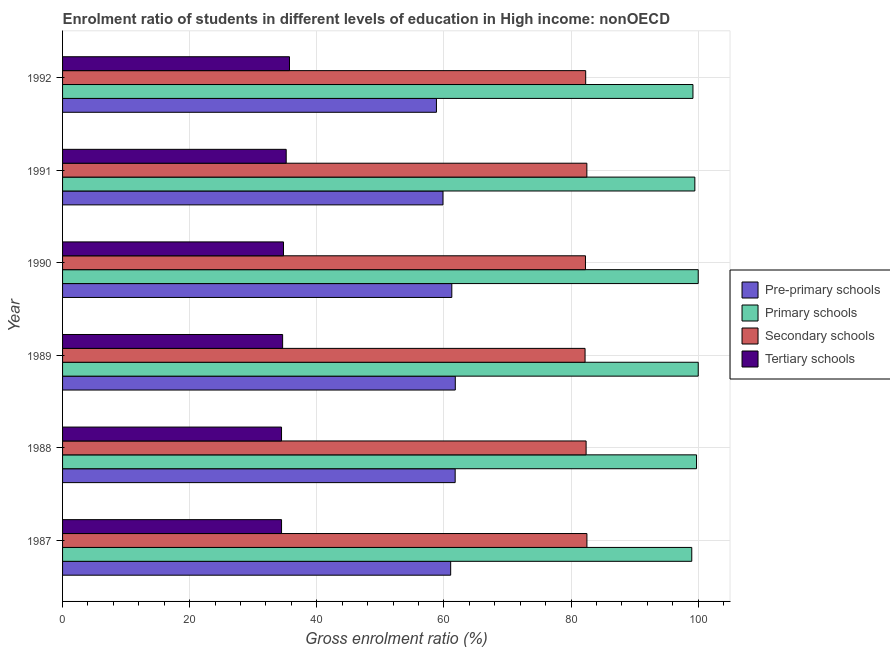Are the number of bars per tick equal to the number of legend labels?
Make the answer very short. Yes. What is the gross enrolment ratio in tertiary schools in 1989?
Provide a short and direct response. 34.62. Across all years, what is the maximum gross enrolment ratio in tertiary schools?
Offer a very short reply. 35.71. Across all years, what is the minimum gross enrolment ratio in primary schools?
Your answer should be compact. 99. What is the total gross enrolment ratio in pre-primary schools in the graph?
Provide a succinct answer. 364.56. What is the difference between the gross enrolment ratio in secondary schools in 1987 and that in 1990?
Your answer should be compact. 0.23. What is the difference between the gross enrolment ratio in pre-primary schools in 1987 and the gross enrolment ratio in secondary schools in 1992?
Keep it short and to the point. -21.24. What is the average gross enrolment ratio in secondary schools per year?
Your response must be concise. 82.36. In the year 1988, what is the difference between the gross enrolment ratio in tertiary schools and gross enrolment ratio in pre-primary schools?
Make the answer very short. -27.32. Is the difference between the gross enrolment ratio in tertiary schools in 1989 and 1992 greater than the difference between the gross enrolment ratio in primary schools in 1989 and 1992?
Your response must be concise. No. What is the difference between the highest and the second highest gross enrolment ratio in tertiary schools?
Your response must be concise. 0.52. What is the difference between the highest and the lowest gross enrolment ratio in primary schools?
Provide a succinct answer. 1.02. In how many years, is the gross enrolment ratio in pre-primary schools greater than the average gross enrolment ratio in pre-primary schools taken over all years?
Make the answer very short. 4. What does the 4th bar from the top in 1990 represents?
Ensure brevity in your answer.  Pre-primary schools. What does the 4th bar from the bottom in 1991 represents?
Provide a short and direct response. Tertiary schools. How many bars are there?
Provide a short and direct response. 24. How many years are there in the graph?
Provide a succinct answer. 6. What is the difference between two consecutive major ticks on the X-axis?
Make the answer very short. 20. Are the values on the major ticks of X-axis written in scientific E-notation?
Offer a very short reply. No. Does the graph contain grids?
Provide a short and direct response. Yes. How many legend labels are there?
Offer a terse response. 4. What is the title of the graph?
Offer a terse response. Enrolment ratio of students in different levels of education in High income: nonOECD. What is the label or title of the Y-axis?
Provide a succinct answer. Year. What is the Gross enrolment ratio (%) of Pre-primary schools in 1987?
Make the answer very short. 61.07. What is the Gross enrolment ratio (%) of Primary schools in 1987?
Offer a terse response. 99. What is the Gross enrolment ratio (%) of Secondary schools in 1987?
Offer a very short reply. 82.5. What is the Gross enrolment ratio (%) in Tertiary schools in 1987?
Keep it short and to the point. 34.46. What is the Gross enrolment ratio (%) in Pre-primary schools in 1988?
Your response must be concise. 61.77. What is the Gross enrolment ratio (%) in Primary schools in 1988?
Offer a very short reply. 99.75. What is the Gross enrolment ratio (%) in Secondary schools in 1988?
Offer a terse response. 82.38. What is the Gross enrolment ratio (%) in Tertiary schools in 1988?
Provide a short and direct response. 34.45. What is the Gross enrolment ratio (%) in Pre-primary schools in 1989?
Keep it short and to the point. 61.79. What is the Gross enrolment ratio (%) of Primary schools in 1989?
Provide a succinct answer. 100.02. What is the Gross enrolment ratio (%) in Secondary schools in 1989?
Provide a short and direct response. 82.21. What is the Gross enrolment ratio (%) in Tertiary schools in 1989?
Your answer should be compact. 34.62. What is the Gross enrolment ratio (%) of Pre-primary schools in 1990?
Ensure brevity in your answer.  61.25. What is the Gross enrolment ratio (%) of Primary schools in 1990?
Give a very brief answer. 100.02. What is the Gross enrolment ratio (%) in Secondary schools in 1990?
Keep it short and to the point. 82.27. What is the Gross enrolment ratio (%) in Tertiary schools in 1990?
Ensure brevity in your answer.  34.76. What is the Gross enrolment ratio (%) of Pre-primary schools in 1991?
Your answer should be compact. 59.86. What is the Gross enrolment ratio (%) in Primary schools in 1991?
Your answer should be very brief. 99.49. What is the Gross enrolment ratio (%) in Secondary schools in 1991?
Provide a short and direct response. 82.49. What is the Gross enrolment ratio (%) in Tertiary schools in 1991?
Your answer should be compact. 35.19. What is the Gross enrolment ratio (%) of Pre-primary schools in 1992?
Your response must be concise. 58.83. What is the Gross enrolment ratio (%) of Primary schools in 1992?
Make the answer very short. 99.19. What is the Gross enrolment ratio (%) of Secondary schools in 1992?
Ensure brevity in your answer.  82.31. What is the Gross enrolment ratio (%) in Tertiary schools in 1992?
Make the answer very short. 35.71. Across all years, what is the maximum Gross enrolment ratio (%) of Pre-primary schools?
Provide a succinct answer. 61.79. Across all years, what is the maximum Gross enrolment ratio (%) in Primary schools?
Provide a short and direct response. 100.02. Across all years, what is the maximum Gross enrolment ratio (%) of Secondary schools?
Keep it short and to the point. 82.5. Across all years, what is the maximum Gross enrolment ratio (%) of Tertiary schools?
Make the answer very short. 35.71. Across all years, what is the minimum Gross enrolment ratio (%) in Pre-primary schools?
Provide a short and direct response. 58.83. Across all years, what is the minimum Gross enrolment ratio (%) of Primary schools?
Your answer should be very brief. 99. Across all years, what is the minimum Gross enrolment ratio (%) of Secondary schools?
Ensure brevity in your answer.  82.21. Across all years, what is the minimum Gross enrolment ratio (%) of Tertiary schools?
Make the answer very short. 34.45. What is the total Gross enrolment ratio (%) of Pre-primary schools in the graph?
Ensure brevity in your answer.  364.56. What is the total Gross enrolment ratio (%) of Primary schools in the graph?
Ensure brevity in your answer.  597.46. What is the total Gross enrolment ratio (%) in Secondary schools in the graph?
Provide a succinct answer. 494.17. What is the total Gross enrolment ratio (%) in Tertiary schools in the graph?
Give a very brief answer. 209.19. What is the difference between the Gross enrolment ratio (%) of Pre-primary schools in 1987 and that in 1988?
Offer a very short reply. -0.71. What is the difference between the Gross enrolment ratio (%) of Primary schools in 1987 and that in 1988?
Give a very brief answer. -0.75. What is the difference between the Gross enrolment ratio (%) in Secondary schools in 1987 and that in 1988?
Your answer should be compact. 0.13. What is the difference between the Gross enrolment ratio (%) in Tertiary schools in 1987 and that in 1988?
Your answer should be compact. 0. What is the difference between the Gross enrolment ratio (%) in Pre-primary schools in 1987 and that in 1989?
Your response must be concise. -0.73. What is the difference between the Gross enrolment ratio (%) of Primary schools in 1987 and that in 1989?
Your answer should be very brief. -1.02. What is the difference between the Gross enrolment ratio (%) in Secondary schools in 1987 and that in 1989?
Offer a very short reply. 0.29. What is the difference between the Gross enrolment ratio (%) in Tertiary schools in 1987 and that in 1989?
Your response must be concise. -0.17. What is the difference between the Gross enrolment ratio (%) in Pre-primary schools in 1987 and that in 1990?
Offer a terse response. -0.18. What is the difference between the Gross enrolment ratio (%) in Primary schools in 1987 and that in 1990?
Keep it short and to the point. -1.01. What is the difference between the Gross enrolment ratio (%) in Secondary schools in 1987 and that in 1990?
Give a very brief answer. 0.23. What is the difference between the Gross enrolment ratio (%) in Tertiary schools in 1987 and that in 1990?
Your answer should be very brief. -0.31. What is the difference between the Gross enrolment ratio (%) of Pre-primary schools in 1987 and that in 1991?
Your answer should be very brief. 1.21. What is the difference between the Gross enrolment ratio (%) in Primary schools in 1987 and that in 1991?
Offer a very short reply. -0.48. What is the difference between the Gross enrolment ratio (%) in Secondary schools in 1987 and that in 1991?
Ensure brevity in your answer.  0.01. What is the difference between the Gross enrolment ratio (%) in Tertiary schools in 1987 and that in 1991?
Offer a terse response. -0.73. What is the difference between the Gross enrolment ratio (%) of Pre-primary schools in 1987 and that in 1992?
Provide a succinct answer. 2.24. What is the difference between the Gross enrolment ratio (%) in Primary schools in 1987 and that in 1992?
Offer a very short reply. -0.19. What is the difference between the Gross enrolment ratio (%) of Secondary schools in 1987 and that in 1992?
Make the answer very short. 0.19. What is the difference between the Gross enrolment ratio (%) of Tertiary schools in 1987 and that in 1992?
Your answer should be very brief. -1.25. What is the difference between the Gross enrolment ratio (%) in Pre-primary schools in 1988 and that in 1989?
Keep it short and to the point. -0.02. What is the difference between the Gross enrolment ratio (%) of Primary schools in 1988 and that in 1989?
Provide a succinct answer. -0.27. What is the difference between the Gross enrolment ratio (%) of Secondary schools in 1988 and that in 1989?
Offer a very short reply. 0.16. What is the difference between the Gross enrolment ratio (%) in Tertiary schools in 1988 and that in 1989?
Keep it short and to the point. -0.17. What is the difference between the Gross enrolment ratio (%) of Pre-primary schools in 1988 and that in 1990?
Your answer should be compact. 0.53. What is the difference between the Gross enrolment ratio (%) of Primary schools in 1988 and that in 1990?
Offer a terse response. -0.27. What is the difference between the Gross enrolment ratio (%) in Secondary schools in 1988 and that in 1990?
Your answer should be very brief. 0.1. What is the difference between the Gross enrolment ratio (%) in Tertiary schools in 1988 and that in 1990?
Your answer should be compact. -0.31. What is the difference between the Gross enrolment ratio (%) in Pre-primary schools in 1988 and that in 1991?
Provide a succinct answer. 1.92. What is the difference between the Gross enrolment ratio (%) of Primary schools in 1988 and that in 1991?
Your response must be concise. 0.27. What is the difference between the Gross enrolment ratio (%) of Secondary schools in 1988 and that in 1991?
Your response must be concise. -0.12. What is the difference between the Gross enrolment ratio (%) in Tertiary schools in 1988 and that in 1991?
Your response must be concise. -0.74. What is the difference between the Gross enrolment ratio (%) in Pre-primary schools in 1988 and that in 1992?
Your answer should be very brief. 2.95. What is the difference between the Gross enrolment ratio (%) of Primary schools in 1988 and that in 1992?
Keep it short and to the point. 0.56. What is the difference between the Gross enrolment ratio (%) of Secondary schools in 1988 and that in 1992?
Provide a short and direct response. 0.07. What is the difference between the Gross enrolment ratio (%) of Tertiary schools in 1988 and that in 1992?
Make the answer very short. -1.25. What is the difference between the Gross enrolment ratio (%) of Pre-primary schools in 1989 and that in 1990?
Give a very brief answer. 0.55. What is the difference between the Gross enrolment ratio (%) of Primary schools in 1989 and that in 1990?
Your answer should be very brief. 0. What is the difference between the Gross enrolment ratio (%) in Secondary schools in 1989 and that in 1990?
Offer a terse response. -0.06. What is the difference between the Gross enrolment ratio (%) of Tertiary schools in 1989 and that in 1990?
Make the answer very short. -0.14. What is the difference between the Gross enrolment ratio (%) of Pre-primary schools in 1989 and that in 1991?
Make the answer very short. 1.94. What is the difference between the Gross enrolment ratio (%) of Primary schools in 1989 and that in 1991?
Keep it short and to the point. 0.53. What is the difference between the Gross enrolment ratio (%) in Secondary schools in 1989 and that in 1991?
Give a very brief answer. -0.28. What is the difference between the Gross enrolment ratio (%) of Tertiary schools in 1989 and that in 1991?
Provide a short and direct response. -0.56. What is the difference between the Gross enrolment ratio (%) of Pre-primary schools in 1989 and that in 1992?
Your answer should be compact. 2.97. What is the difference between the Gross enrolment ratio (%) in Primary schools in 1989 and that in 1992?
Offer a terse response. 0.83. What is the difference between the Gross enrolment ratio (%) of Secondary schools in 1989 and that in 1992?
Make the answer very short. -0.1. What is the difference between the Gross enrolment ratio (%) in Tertiary schools in 1989 and that in 1992?
Your answer should be compact. -1.08. What is the difference between the Gross enrolment ratio (%) of Pre-primary schools in 1990 and that in 1991?
Make the answer very short. 1.39. What is the difference between the Gross enrolment ratio (%) in Primary schools in 1990 and that in 1991?
Provide a short and direct response. 0.53. What is the difference between the Gross enrolment ratio (%) of Secondary schools in 1990 and that in 1991?
Offer a very short reply. -0.22. What is the difference between the Gross enrolment ratio (%) of Tertiary schools in 1990 and that in 1991?
Offer a very short reply. -0.42. What is the difference between the Gross enrolment ratio (%) in Pre-primary schools in 1990 and that in 1992?
Your answer should be compact. 2.42. What is the difference between the Gross enrolment ratio (%) of Primary schools in 1990 and that in 1992?
Provide a succinct answer. 0.83. What is the difference between the Gross enrolment ratio (%) of Secondary schools in 1990 and that in 1992?
Your response must be concise. -0.04. What is the difference between the Gross enrolment ratio (%) in Tertiary schools in 1990 and that in 1992?
Your answer should be very brief. -0.94. What is the difference between the Gross enrolment ratio (%) of Pre-primary schools in 1991 and that in 1992?
Provide a short and direct response. 1.03. What is the difference between the Gross enrolment ratio (%) in Primary schools in 1991 and that in 1992?
Ensure brevity in your answer.  0.3. What is the difference between the Gross enrolment ratio (%) of Secondary schools in 1991 and that in 1992?
Give a very brief answer. 0.19. What is the difference between the Gross enrolment ratio (%) of Tertiary schools in 1991 and that in 1992?
Offer a very short reply. -0.52. What is the difference between the Gross enrolment ratio (%) of Pre-primary schools in 1987 and the Gross enrolment ratio (%) of Primary schools in 1988?
Keep it short and to the point. -38.69. What is the difference between the Gross enrolment ratio (%) of Pre-primary schools in 1987 and the Gross enrolment ratio (%) of Secondary schools in 1988?
Provide a succinct answer. -21.31. What is the difference between the Gross enrolment ratio (%) of Pre-primary schools in 1987 and the Gross enrolment ratio (%) of Tertiary schools in 1988?
Offer a very short reply. 26.61. What is the difference between the Gross enrolment ratio (%) of Primary schools in 1987 and the Gross enrolment ratio (%) of Secondary schools in 1988?
Keep it short and to the point. 16.63. What is the difference between the Gross enrolment ratio (%) in Primary schools in 1987 and the Gross enrolment ratio (%) in Tertiary schools in 1988?
Provide a succinct answer. 64.55. What is the difference between the Gross enrolment ratio (%) of Secondary schools in 1987 and the Gross enrolment ratio (%) of Tertiary schools in 1988?
Your response must be concise. 48.05. What is the difference between the Gross enrolment ratio (%) in Pre-primary schools in 1987 and the Gross enrolment ratio (%) in Primary schools in 1989?
Your response must be concise. -38.95. What is the difference between the Gross enrolment ratio (%) of Pre-primary schools in 1987 and the Gross enrolment ratio (%) of Secondary schools in 1989?
Provide a short and direct response. -21.15. What is the difference between the Gross enrolment ratio (%) in Pre-primary schools in 1987 and the Gross enrolment ratio (%) in Tertiary schools in 1989?
Make the answer very short. 26.44. What is the difference between the Gross enrolment ratio (%) in Primary schools in 1987 and the Gross enrolment ratio (%) in Secondary schools in 1989?
Ensure brevity in your answer.  16.79. What is the difference between the Gross enrolment ratio (%) in Primary schools in 1987 and the Gross enrolment ratio (%) in Tertiary schools in 1989?
Make the answer very short. 64.38. What is the difference between the Gross enrolment ratio (%) of Secondary schools in 1987 and the Gross enrolment ratio (%) of Tertiary schools in 1989?
Provide a succinct answer. 47.88. What is the difference between the Gross enrolment ratio (%) of Pre-primary schools in 1987 and the Gross enrolment ratio (%) of Primary schools in 1990?
Keep it short and to the point. -38.95. What is the difference between the Gross enrolment ratio (%) of Pre-primary schools in 1987 and the Gross enrolment ratio (%) of Secondary schools in 1990?
Offer a very short reply. -21.21. What is the difference between the Gross enrolment ratio (%) of Pre-primary schools in 1987 and the Gross enrolment ratio (%) of Tertiary schools in 1990?
Your answer should be very brief. 26.3. What is the difference between the Gross enrolment ratio (%) of Primary schools in 1987 and the Gross enrolment ratio (%) of Secondary schools in 1990?
Your response must be concise. 16.73. What is the difference between the Gross enrolment ratio (%) of Primary schools in 1987 and the Gross enrolment ratio (%) of Tertiary schools in 1990?
Provide a short and direct response. 64.24. What is the difference between the Gross enrolment ratio (%) of Secondary schools in 1987 and the Gross enrolment ratio (%) of Tertiary schools in 1990?
Provide a succinct answer. 47.74. What is the difference between the Gross enrolment ratio (%) in Pre-primary schools in 1987 and the Gross enrolment ratio (%) in Primary schools in 1991?
Your answer should be compact. -38.42. What is the difference between the Gross enrolment ratio (%) in Pre-primary schools in 1987 and the Gross enrolment ratio (%) in Secondary schools in 1991?
Offer a very short reply. -21.43. What is the difference between the Gross enrolment ratio (%) of Pre-primary schools in 1987 and the Gross enrolment ratio (%) of Tertiary schools in 1991?
Make the answer very short. 25.88. What is the difference between the Gross enrolment ratio (%) of Primary schools in 1987 and the Gross enrolment ratio (%) of Secondary schools in 1991?
Your answer should be compact. 16.51. What is the difference between the Gross enrolment ratio (%) in Primary schools in 1987 and the Gross enrolment ratio (%) in Tertiary schools in 1991?
Your answer should be compact. 63.81. What is the difference between the Gross enrolment ratio (%) in Secondary schools in 1987 and the Gross enrolment ratio (%) in Tertiary schools in 1991?
Make the answer very short. 47.32. What is the difference between the Gross enrolment ratio (%) of Pre-primary schools in 1987 and the Gross enrolment ratio (%) of Primary schools in 1992?
Your answer should be very brief. -38.12. What is the difference between the Gross enrolment ratio (%) of Pre-primary schools in 1987 and the Gross enrolment ratio (%) of Secondary schools in 1992?
Offer a very short reply. -21.24. What is the difference between the Gross enrolment ratio (%) of Pre-primary schools in 1987 and the Gross enrolment ratio (%) of Tertiary schools in 1992?
Offer a very short reply. 25.36. What is the difference between the Gross enrolment ratio (%) of Primary schools in 1987 and the Gross enrolment ratio (%) of Secondary schools in 1992?
Your response must be concise. 16.69. What is the difference between the Gross enrolment ratio (%) of Primary schools in 1987 and the Gross enrolment ratio (%) of Tertiary schools in 1992?
Offer a very short reply. 63.29. What is the difference between the Gross enrolment ratio (%) of Secondary schools in 1987 and the Gross enrolment ratio (%) of Tertiary schools in 1992?
Your response must be concise. 46.8. What is the difference between the Gross enrolment ratio (%) of Pre-primary schools in 1988 and the Gross enrolment ratio (%) of Primary schools in 1989?
Ensure brevity in your answer.  -38.25. What is the difference between the Gross enrolment ratio (%) in Pre-primary schools in 1988 and the Gross enrolment ratio (%) in Secondary schools in 1989?
Offer a very short reply. -20.44. What is the difference between the Gross enrolment ratio (%) of Pre-primary schools in 1988 and the Gross enrolment ratio (%) of Tertiary schools in 1989?
Give a very brief answer. 27.15. What is the difference between the Gross enrolment ratio (%) in Primary schools in 1988 and the Gross enrolment ratio (%) in Secondary schools in 1989?
Your answer should be very brief. 17.54. What is the difference between the Gross enrolment ratio (%) of Primary schools in 1988 and the Gross enrolment ratio (%) of Tertiary schools in 1989?
Give a very brief answer. 65.13. What is the difference between the Gross enrolment ratio (%) of Secondary schools in 1988 and the Gross enrolment ratio (%) of Tertiary schools in 1989?
Offer a terse response. 47.75. What is the difference between the Gross enrolment ratio (%) in Pre-primary schools in 1988 and the Gross enrolment ratio (%) in Primary schools in 1990?
Offer a very short reply. -38.24. What is the difference between the Gross enrolment ratio (%) of Pre-primary schools in 1988 and the Gross enrolment ratio (%) of Secondary schools in 1990?
Offer a very short reply. -20.5. What is the difference between the Gross enrolment ratio (%) in Pre-primary schools in 1988 and the Gross enrolment ratio (%) in Tertiary schools in 1990?
Offer a very short reply. 27.01. What is the difference between the Gross enrolment ratio (%) of Primary schools in 1988 and the Gross enrolment ratio (%) of Secondary schools in 1990?
Give a very brief answer. 17.48. What is the difference between the Gross enrolment ratio (%) of Primary schools in 1988 and the Gross enrolment ratio (%) of Tertiary schools in 1990?
Your answer should be compact. 64.99. What is the difference between the Gross enrolment ratio (%) in Secondary schools in 1988 and the Gross enrolment ratio (%) in Tertiary schools in 1990?
Your answer should be compact. 47.61. What is the difference between the Gross enrolment ratio (%) of Pre-primary schools in 1988 and the Gross enrolment ratio (%) of Primary schools in 1991?
Your answer should be very brief. -37.71. What is the difference between the Gross enrolment ratio (%) of Pre-primary schools in 1988 and the Gross enrolment ratio (%) of Secondary schools in 1991?
Keep it short and to the point. -20.72. What is the difference between the Gross enrolment ratio (%) in Pre-primary schools in 1988 and the Gross enrolment ratio (%) in Tertiary schools in 1991?
Your answer should be compact. 26.59. What is the difference between the Gross enrolment ratio (%) in Primary schools in 1988 and the Gross enrolment ratio (%) in Secondary schools in 1991?
Your answer should be very brief. 17.26. What is the difference between the Gross enrolment ratio (%) in Primary schools in 1988 and the Gross enrolment ratio (%) in Tertiary schools in 1991?
Your answer should be compact. 64.56. What is the difference between the Gross enrolment ratio (%) in Secondary schools in 1988 and the Gross enrolment ratio (%) in Tertiary schools in 1991?
Offer a terse response. 47.19. What is the difference between the Gross enrolment ratio (%) of Pre-primary schools in 1988 and the Gross enrolment ratio (%) of Primary schools in 1992?
Your response must be concise. -37.41. What is the difference between the Gross enrolment ratio (%) in Pre-primary schools in 1988 and the Gross enrolment ratio (%) in Secondary schools in 1992?
Offer a very short reply. -20.54. What is the difference between the Gross enrolment ratio (%) in Pre-primary schools in 1988 and the Gross enrolment ratio (%) in Tertiary schools in 1992?
Provide a short and direct response. 26.07. What is the difference between the Gross enrolment ratio (%) in Primary schools in 1988 and the Gross enrolment ratio (%) in Secondary schools in 1992?
Make the answer very short. 17.44. What is the difference between the Gross enrolment ratio (%) of Primary schools in 1988 and the Gross enrolment ratio (%) of Tertiary schools in 1992?
Provide a succinct answer. 64.04. What is the difference between the Gross enrolment ratio (%) of Secondary schools in 1988 and the Gross enrolment ratio (%) of Tertiary schools in 1992?
Your response must be concise. 46.67. What is the difference between the Gross enrolment ratio (%) in Pre-primary schools in 1989 and the Gross enrolment ratio (%) in Primary schools in 1990?
Provide a succinct answer. -38.22. What is the difference between the Gross enrolment ratio (%) in Pre-primary schools in 1989 and the Gross enrolment ratio (%) in Secondary schools in 1990?
Offer a terse response. -20.48. What is the difference between the Gross enrolment ratio (%) of Pre-primary schools in 1989 and the Gross enrolment ratio (%) of Tertiary schools in 1990?
Keep it short and to the point. 27.03. What is the difference between the Gross enrolment ratio (%) in Primary schools in 1989 and the Gross enrolment ratio (%) in Secondary schools in 1990?
Make the answer very short. 17.74. What is the difference between the Gross enrolment ratio (%) of Primary schools in 1989 and the Gross enrolment ratio (%) of Tertiary schools in 1990?
Offer a very short reply. 65.26. What is the difference between the Gross enrolment ratio (%) in Secondary schools in 1989 and the Gross enrolment ratio (%) in Tertiary schools in 1990?
Your answer should be compact. 47.45. What is the difference between the Gross enrolment ratio (%) of Pre-primary schools in 1989 and the Gross enrolment ratio (%) of Primary schools in 1991?
Offer a very short reply. -37.69. What is the difference between the Gross enrolment ratio (%) of Pre-primary schools in 1989 and the Gross enrolment ratio (%) of Secondary schools in 1991?
Make the answer very short. -20.7. What is the difference between the Gross enrolment ratio (%) of Pre-primary schools in 1989 and the Gross enrolment ratio (%) of Tertiary schools in 1991?
Ensure brevity in your answer.  26.61. What is the difference between the Gross enrolment ratio (%) of Primary schools in 1989 and the Gross enrolment ratio (%) of Secondary schools in 1991?
Ensure brevity in your answer.  17.52. What is the difference between the Gross enrolment ratio (%) of Primary schools in 1989 and the Gross enrolment ratio (%) of Tertiary schools in 1991?
Offer a terse response. 64.83. What is the difference between the Gross enrolment ratio (%) in Secondary schools in 1989 and the Gross enrolment ratio (%) in Tertiary schools in 1991?
Provide a short and direct response. 47.02. What is the difference between the Gross enrolment ratio (%) in Pre-primary schools in 1989 and the Gross enrolment ratio (%) in Primary schools in 1992?
Your answer should be compact. -37.39. What is the difference between the Gross enrolment ratio (%) in Pre-primary schools in 1989 and the Gross enrolment ratio (%) in Secondary schools in 1992?
Your answer should be compact. -20.51. What is the difference between the Gross enrolment ratio (%) of Pre-primary schools in 1989 and the Gross enrolment ratio (%) of Tertiary schools in 1992?
Make the answer very short. 26.09. What is the difference between the Gross enrolment ratio (%) of Primary schools in 1989 and the Gross enrolment ratio (%) of Secondary schools in 1992?
Make the answer very short. 17.71. What is the difference between the Gross enrolment ratio (%) in Primary schools in 1989 and the Gross enrolment ratio (%) in Tertiary schools in 1992?
Offer a very short reply. 64.31. What is the difference between the Gross enrolment ratio (%) in Secondary schools in 1989 and the Gross enrolment ratio (%) in Tertiary schools in 1992?
Keep it short and to the point. 46.5. What is the difference between the Gross enrolment ratio (%) of Pre-primary schools in 1990 and the Gross enrolment ratio (%) of Primary schools in 1991?
Ensure brevity in your answer.  -38.24. What is the difference between the Gross enrolment ratio (%) of Pre-primary schools in 1990 and the Gross enrolment ratio (%) of Secondary schools in 1991?
Keep it short and to the point. -21.25. What is the difference between the Gross enrolment ratio (%) of Pre-primary schools in 1990 and the Gross enrolment ratio (%) of Tertiary schools in 1991?
Give a very brief answer. 26.06. What is the difference between the Gross enrolment ratio (%) of Primary schools in 1990 and the Gross enrolment ratio (%) of Secondary schools in 1991?
Provide a short and direct response. 17.52. What is the difference between the Gross enrolment ratio (%) in Primary schools in 1990 and the Gross enrolment ratio (%) in Tertiary schools in 1991?
Your response must be concise. 64.83. What is the difference between the Gross enrolment ratio (%) in Secondary schools in 1990 and the Gross enrolment ratio (%) in Tertiary schools in 1991?
Provide a succinct answer. 47.09. What is the difference between the Gross enrolment ratio (%) in Pre-primary schools in 1990 and the Gross enrolment ratio (%) in Primary schools in 1992?
Ensure brevity in your answer.  -37.94. What is the difference between the Gross enrolment ratio (%) of Pre-primary schools in 1990 and the Gross enrolment ratio (%) of Secondary schools in 1992?
Offer a very short reply. -21.06. What is the difference between the Gross enrolment ratio (%) in Pre-primary schools in 1990 and the Gross enrolment ratio (%) in Tertiary schools in 1992?
Your answer should be very brief. 25.54. What is the difference between the Gross enrolment ratio (%) of Primary schools in 1990 and the Gross enrolment ratio (%) of Secondary schools in 1992?
Offer a very short reply. 17.71. What is the difference between the Gross enrolment ratio (%) of Primary schools in 1990 and the Gross enrolment ratio (%) of Tertiary schools in 1992?
Ensure brevity in your answer.  64.31. What is the difference between the Gross enrolment ratio (%) of Secondary schools in 1990 and the Gross enrolment ratio (%) of Tertiary schools in 1992?
Your answer should be very brief. 46.57. What is the difference between the Gross enrolment ratio (%) in Pre-primary schools in 1991 and the Gross enrolment ratio (%) in Primary schools in 1992?
Offer a terse response. -39.33. What is the difference between the Gross enrolment ratio (%) of Pre-primary schools in 1991 and the Gross enrolment ratio (%) of Secondary schools in 1992?
Provide a succinct answer. -22.45. What is the difference between the Gross enrolment ratio (%) of Pre-primary schools in 1991 and the Gross enrolment ratio (%) of Tertiary schools in 1992?
Make the answer very short. 24.15. What is the difference between the Gross enrolment ratio (%) of Primary schools in 1991 and the Gross enrolment ratio (%) of Secondary schools in 1992?
Make the answer very short. 17.18. What is the difference between the Gross enrolment ratio (%) in Primary schools in 1991 and the Gross enrolment ratio (%) in Tertiary schools in 1992?
Your response must be concise. 63.78. What is the difference between the Gross enrolment ratio (%) of Secondary schools in 1991 and the Gross enrolment ratio (%) of Tertiary schools in 1992?
Your answer should be compact. 46.79. What is the average Gross enrolment ratio (%) in Pre-primary schools per year?
Your answer should be compact. 60.76. What is the average Gross enrolment ratio (%) of Primary schools per year?
Ensure brevity in your answer.  99.58. What is the average Gross enrolment ratio (%) of Secondary schools per year?
Offer a terse response. 82.36. What is the average Gross enrolment ratio (%) in Tertiary schools per year?
Offer a very short reply. 34.87. In the year 1987, what is the difference between the Gross enrolment ratio (%) of Pre-primary schools and Gross enrolment ratio (%) of Primary schools?
Ensure brevity in your answer.  -37.94. In the year 1987, what is the difference between the Gross enrolment ratio (%) of Pre-primary schools and Gross enrolment ratio (%) of Secondary schools?
Give a very brief answer. -21.44. In the year 1987, what is the difference between the Gross enrolment ratio (%) in Pre-primary schools and Gross enrolment ratio (%) in Tertiary schools?
Your answer should be very brief. 26.61. In the year 1987, what is the difference between the Gross enrolment ratio (%) in Primary schools and Gross enrolment ratio (%) in Secondary schools?
Provide a short and direct response. 16.5. In the year 1987, what is the difference between the Gross enrolment ratio (%) in Primary schools and Gross enrolment ratio (%) in Tertiary schools?
Your response must be concise. 64.54. In the year 1987, what is the difference between the Gross enrolment ratio (%) of Secondary schools and Gross enrolment ratio (%) of Tertiary schools?
Give a very brief answer. 48.05. In the year 1988, what is the difference between the Gross enrolment ratio (%) of Pre-primary schools and Gross enrolment ratio (%) of Primary schools?
Offer a very short reply. -37.98. In the year 1988, what is the difference between the Gross enrolment ratio (%) in Pre-primary schools and Gross enrolment ratio (%) in Secondary schools?
Offer a very short reply. -20.6. In the year 1988, what is the difference between the Gross enrolment ratio (%) of Pre-primary schools and Gross enrolment ratio (%) of Tertiary schools?
Your answer should be compact. 27.32. In the year 1988, what is the difference between the Gross enrolment ratio (%) of Primary schools and Gross enrolment ratio (%) of Secondary schools?
Provide a short and direct response. 17.38. In the year 1988, what is the difference between the Gross enrolment ratio (%) in Primary schools and Gross enrolment ratio (%) in Tertiary schools?
Provide a short and direct response. 65.3. In the year 1988, what is the difference between the Gross enrolment ratio (%) of Secondary schools and Gross enrolment ratio (%) of Tertiary schools?
Offer a terse response. 47.92. In the year 1989, what is the difference between the Gross enrolment ratio (%) of Pre-primary schools and Gross enrolment ratio (%) of Primary schools?
Give a very brief answer. -38.22. In the year 1989, what is the difference between the Gross enrolment ratio (%) of Pre-primary schools and Gross enrolment ratio (%) of Secondary schools?
Provide a succinct answer. -20.42. In the year 1989, what is the difference between the Gross enrolment ratio (%) of Pre-primary schools and Gross enrolment ratio (%) of Tertiary schools?
Keep it short and to the point. 27.17. In the year 1989, what is the difference between the Gross enrolment ratio (%) of Primary schools and Gross enrolment ratio (%) of Secondary schools?
Offer a terse response. 17.81. In the year 1989, what is the difference between the Gross enrolment ratio (%) of Primary schools and Gross enrolment ratio (%) of Tertiary schools?
Offer a very short reply. 65.39. In the year 1989, what is the difference between the Gross enrolment ratio (%) in Secondary schools and Gross enrolment ratio (%) in Tertiary schools?
Ensure brevity in your answer.  47.59. In the year 1990, what is the difference between the Gross enrolment ratio (%) of Pre-primary schools and Gross enrolment ratio (%) of Primary schools?
Give a very brief answer. -38.77. In the year 1990, what is the difference between the Gross enrolment ratio (%) of Pre-primary schools and Gross enrolment ratio (%) of Secondary schools?
Offer a very short reply. -21.03. In the year 1990, what is the difference between the Gross enrolment ratio (%) of Pre-primary schools and Gross enrolment ratio (%) of Tertiary schools?
Keep it short and to the point. 26.48. In the year 1990, what is the difference between the Gross enrolment ratio (%) of Primary schools and Gross enrolment ratio (%) of Secondary schools?
Give a very brief answer. 17.74. In the year 1990, what is the difference between the Gross enrolment ratio (%) of Primary schools and Gross enrolment ratio (%) of Tertiary schools?
Make the answer very short. 65.25. In the year 1990, what is the difference between the Gross enrolment ratio (%) in Secondary schools and Gross enrolment ratio (%) in Tertiary schools?
Offer a very short reply. 47.51. In the year 1991, what is the difference between the Gross enrolment ratio (%) in Pre-primary schools and Gross enrolment ratio (%) in Primary schools?
Give a very brief answer. -39.63. In the year 1991, what is the difference between the Gross enrolment ratio (%) of Pre-primary schools and Gross enrolment ratio (%) of Secondary schools?
Offer a very short reply. -22.64. In the year 1991, what is the difference between the Gross enrolment ratio (%) of Pre-primary schools and Gross enrolment ratio (%) of Tertiary schools?
Your answer should be compact. 24.67. In the year 1991, what is the difference between the Gross enrolment ratio (%) of Primary schools and Gross enrolment ratio (%) of Secondary schools?
Your answer should be compact. 16.99. In the year 1991, what is the difference between the Gross enrolment ratio (%) of Primary schools and Gross enrolment ratio (%) of Tertiary schools?
Offer a very short reply. 64.3. In the year 1991, what is the difference between the Gross enrolment ratio (%) in Secondary schools and Gross enrolment ratio (%) in Tertiary schools?
Your response must be concise. 47.31. In the year 1992, what is the difference between the Gross enrolment ratio (%) in Pre-primary schools and Gross enrolment ratio (%) in Primary schools?
Your answer should be very brief. -40.36. In the year 1992, what is the difference between the Gross enrolment ratio (%) of Pre-primary schools and Gross enrolment ratio (%) of Secondary schools?
Give a very brief answer. -23.48. In the year 1992, what is the difference between the Gross enrolment ratio (%) of Pre-primary schools and Gross enrolment ratio (%) of Tertiary schools?
Ensure brevity in your answer.  23.12. In the year 1992, what is the difference between the Gross enrolment ratio (%) in Primary schools and Gross enrolment ratio (%) in Secondary schools?
Give a very brief answer. 16.88. In the year 1992, what is the difference between the Gross enrolment ratio (%) of Primary schools and Gross enrolment ratio (%) of Tertiary schools?
Keep it short and to the point. 63.48. In the year 1992, what is the difference between the Gross enrolment ratio (%) of Secondary schools and Gross enrolment ratio (%) of Tertiary schools?
Ensure brevity in your answer.  46.6. What is the ratio of the Gross enrolment ratio (%) of Tertiary schools in 1987 to that in 1988?
Your response must be concise. 1. What is the ratio of the Gross enrolment ratio (%) in Pre-primary schools in 1987 to that in 1989?
Make the answer very short. 0.99. What is the ratio of the Gross enrolment ratio (%) in Primary schools in 1987 to that in 1989?
Your answer should be compact. 0.99. What is the ratio of the Gross enrolment ratio (%) in Tertiary schools in 1987 to that in 1989?
Give a very brief answer. 1. What is the ratio of the Gross enrolment ratio (%) in Primary schools in 1987 to that in 1990?
Make the answer very short. 0.99. What is the ratio of the Gross enrolment ratio (%) in Tertiary schools in 1987 to that in 1990?
Your response must be concise. 0.99. What is the ratio of the Gross enrolment ratio (%) in Pre-primary schools in 1987 to that in 1991?
Keep it short and to the point. 1.02. What is the ratio of the Gross enrolment ratio (%) of Primary schools in 1987 to that in 1991?
Ensure brevity in your answer.  1. What is the ratio of the Gross enrolment ratio (%) in Tertiary schools in 1987 to that in 1991?
Your answer should be very brief. 0.98. What is the ratio of the Gross enrolment ratio (%) in Pre-primary schools in 1987 to that in 1992?
Give a very brief answer. 1.04. What is the ratio of the Gross enrolment ratio (%) of Secondary schools in 1987 to that in 1992?
Make the answer very short. 1. What is the ratio of the Gross enrolment ratio (%) of Primary schools in 1988 to that in 1989?
Provide a succinct answer. 1. What is the ratio of the Gross enrolment ratio (%) of Secondary schools in 1988 to that in 1989?
Provide a succinct answer. 1. What is the ratio of the Gross enrolment ratio (%) in Pre-primary schools in 1988 to that in 1990?
Offer a terse response. 1.01. What is the ratio of the Gross enrolment ratio (%) in Primary schools in 1988 to that in 1990?
Your response must be concise. 1. What is the ratio of the Gross enrolment ratio (%) of Pre-primary schools in 1988 to that in 1991?
Your response must be concise. 1.03. What is the ratio of the Gross enrolment ratio (%) of Secondary schools in 1988 to that in 1991?
Your response must be concise. 1. What is the ratio of the Gross enrolment ratio (%) in Tertiary schools in 1988 to that in 1991?
Provide a succinct answer. 0.98. What is the ratio of the Gross enrolment ratio (%) in Pre-primary schools in 1988 to that in 1992?
Your answer should be very brief. 1.05. What is the ratio of the Gross enrolment ratio (%) in Secondary schools in 1988 to that in 1992?
Your answer should be very brief. 1. What is the ratio of the Gross enrolment ratio (%) of Tertiary schools in 1988 to that in 1992?
Your response must be concise. 0.96. What is the ratio of the Gross enrolment ratio (%) of Pre-primary schools in 1989 to that in 1990?
Offer a very short reply. 1.01. What is the ratio of the Gross enrolment ratio (%) of Primary schools in 1989 to that in 1990?
Your response must be concise. 1. What is the ratio of the Gross enrolment ratio (%) of Secondary schools in 1989 to that in 1990?
Offer a very short reply. 1. What is the ratio of the Gross enrolment ratio (%) in Tertiary schools in 1989 to that in 1990?
Provide a succinct answer. 1. What is the ratio of the Gross enrolment ratio (%) in Pre-primary schools in 1989 to that in 1991?
Offer a very short reply. 1.03. What is the ratio of the Gross enrolment ratio (%) in Primary schools in 1989 to that in 1991?
Provide a succinct answer. 1.01. What is the ratio of the Gross enrolment ratio (%) of Secondary schools in 1989 to that in 1991?
Ensure brevity in your answer.  1. What is the ratio of the Gross enrolment ratio (%) in Pre-primary schools in 1989 to that in 1992?
Your answer should be very brief. 1.05. What is the ratio of the Gross enrolment ratio (%) in Primary schools in 1989 to that in 1992?
Your response must be concise. 1.01. What is the ratio of the Gross enrolment ratio (%) in Tertiary schools in 1989 to that in 1992?
Offer a terse response. 0.97. What is the ratio of the Gross enrolment ratio (%) in Pre-primary schools in 1990 to that in 1991?
Offer a terse response. 1.02. What is the ratio of the Gross enrolment ratio (%) in Primary schools in 1990 to that in 1991?
Your answer should be very brief. 1.01. What is the ratio of the Gross enrolment ratio (%) of Secondary schools in 1990 to that in 1991?
Make the answer very short. 1. What is the ratio of the Gross enrolment ratio (%) of Tertiary schools in 1990 to that in 1991?
Provide a short and direct response. 0.99. What is the ratio of the Gross enrolment ratio (%) in Pre-primary schools in 1990 to that in 1992?
Offer a terse response. 1.04. What is the ratio of the Gross enrolment ratio (%) of Primary schools in 1990 to that in 1992?
Your answer should be very brief. 1.01. What is the ratio of the Gross enrolment ratio (%) in Secondary schools in 1990 to that in 1992?
Offer a very short reply. 1. What is the ratio of the Gross enrolment ratio (%) of Tertiary schools in 1990 to that in 1992?
Make the answer very short. 0.97. What is the ratio of the Gross enrolment ratio (%) in Pre-primary schools in 1991 to that in 1992?
Your response must be concise. 1.02. What is the ratio of the Gross enrolment ratio (%) in Primary schools in 1991 to that in 1992?
Make the answer very short. 1. What is the ratio of the Gross enrolment ratio (%) in Secondary schools in 1991 to that in 1992?
Ensure brevity in your answer.  1. What is the ratio of the Gross enrolment ratio (%) in Tertiary schools in 1991 to that in 1992?
Provide a short and direct response. 0.99. What is the difference between the highest and the second highest Gross enrolment ratio (%) in Pre-primary schools?
Your response must be concise. 0.02. What is the difference between the highest and the second highest Gross enrolment ratio (%) of Primary schools?
Give a very brief answer. 0. What is the difference between the highest and the second highest Gross enrolment ratio (%) in Secondary schools?
Your response must be concise. 0.01. What is the difference between the highest and the second highest Gross enrolment ratio (%) of Tertiary schools?
Your response must be concise. 0.52. What is the difference between the highest and the lowest Gross enrolment ratio (%) of Pre-primary schools?
Offer a terse response. 2.97. What is the difference between the highest and the lowest Gross enrolment ratio (%) in Primary schools?
Your answer should be very brief. 1.02. What is the difference between the highest and the lowest Gross enrolment ratio (%) of Secondary schools?
Offer a very short reply. 0.29. What is the difference between the highest and the lowest Gross enrolment ratio (%) of Tertiary schools?
Offer a terse response. 1.25. 